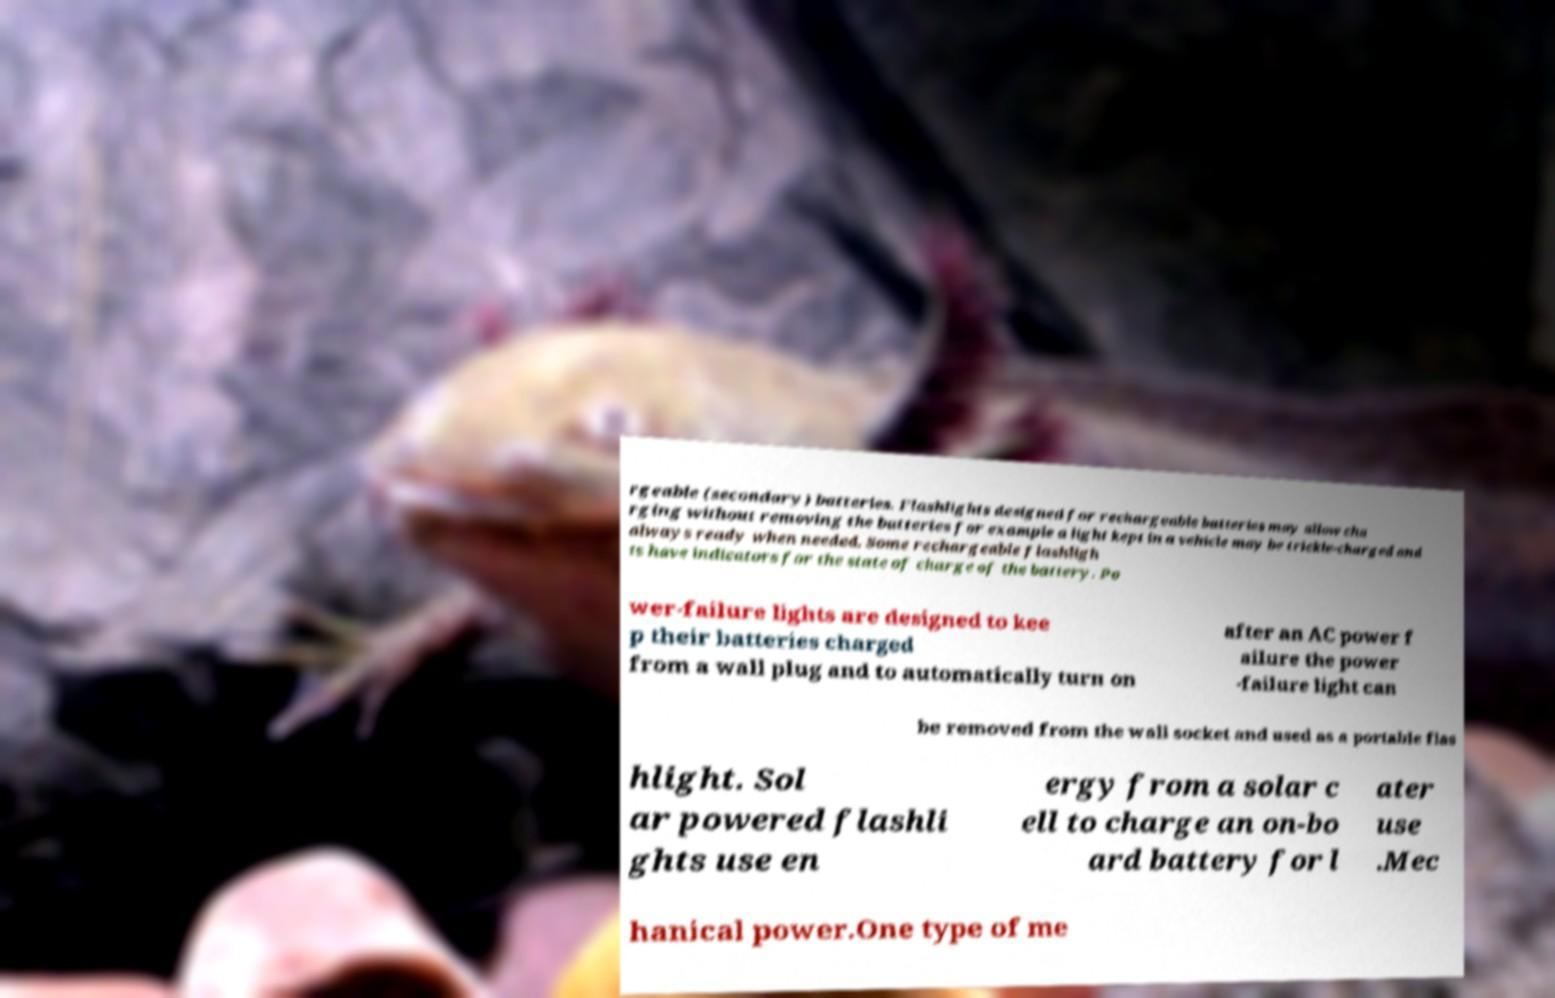Please read and relay the text visible in this image. What does it say? rgeable (secondary) batteries. Flashlights designed for rechargeable batteries may allow cha rging without removing the batteries for example a light kept in a vehicle may be trickle-charged and always ready when needed. Some rechargeable flashligh ts have indicators for the state of charge of the battery. Po wer-failure lights are designed to kee p their batteries charged from a wall plug and to automatically turn on after an AC power f ailure the power -failure light can be removed from the wall socket and used as a portable flas hlight. Sol ar powered flashli ghts use en ergy from a solar c ell to charge an on-bo ard battery for l ater use .Mec hanical power.One type of me 